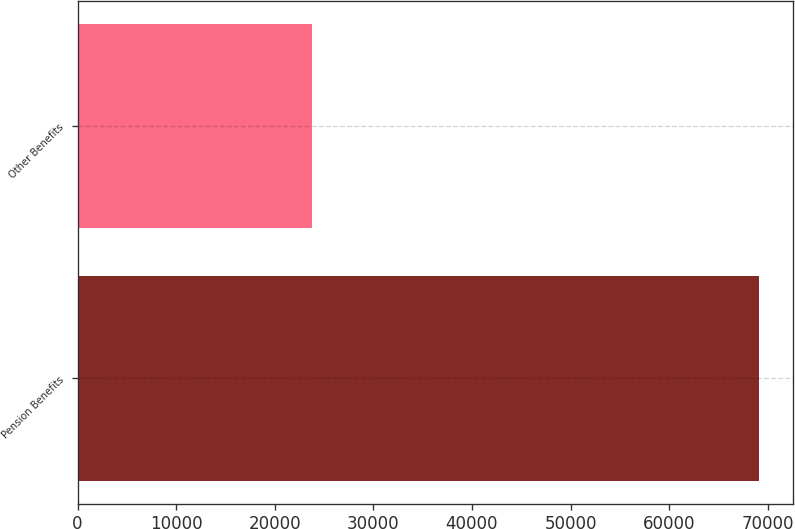Convert chart to OTSL. <chart><loc_0><loc_0><loc_500><loc_500><bar_chart><fcel>Pension Benefits<fcel>Other Benefits<nl><fcel>69085<fcel>23796<nl></chart> 